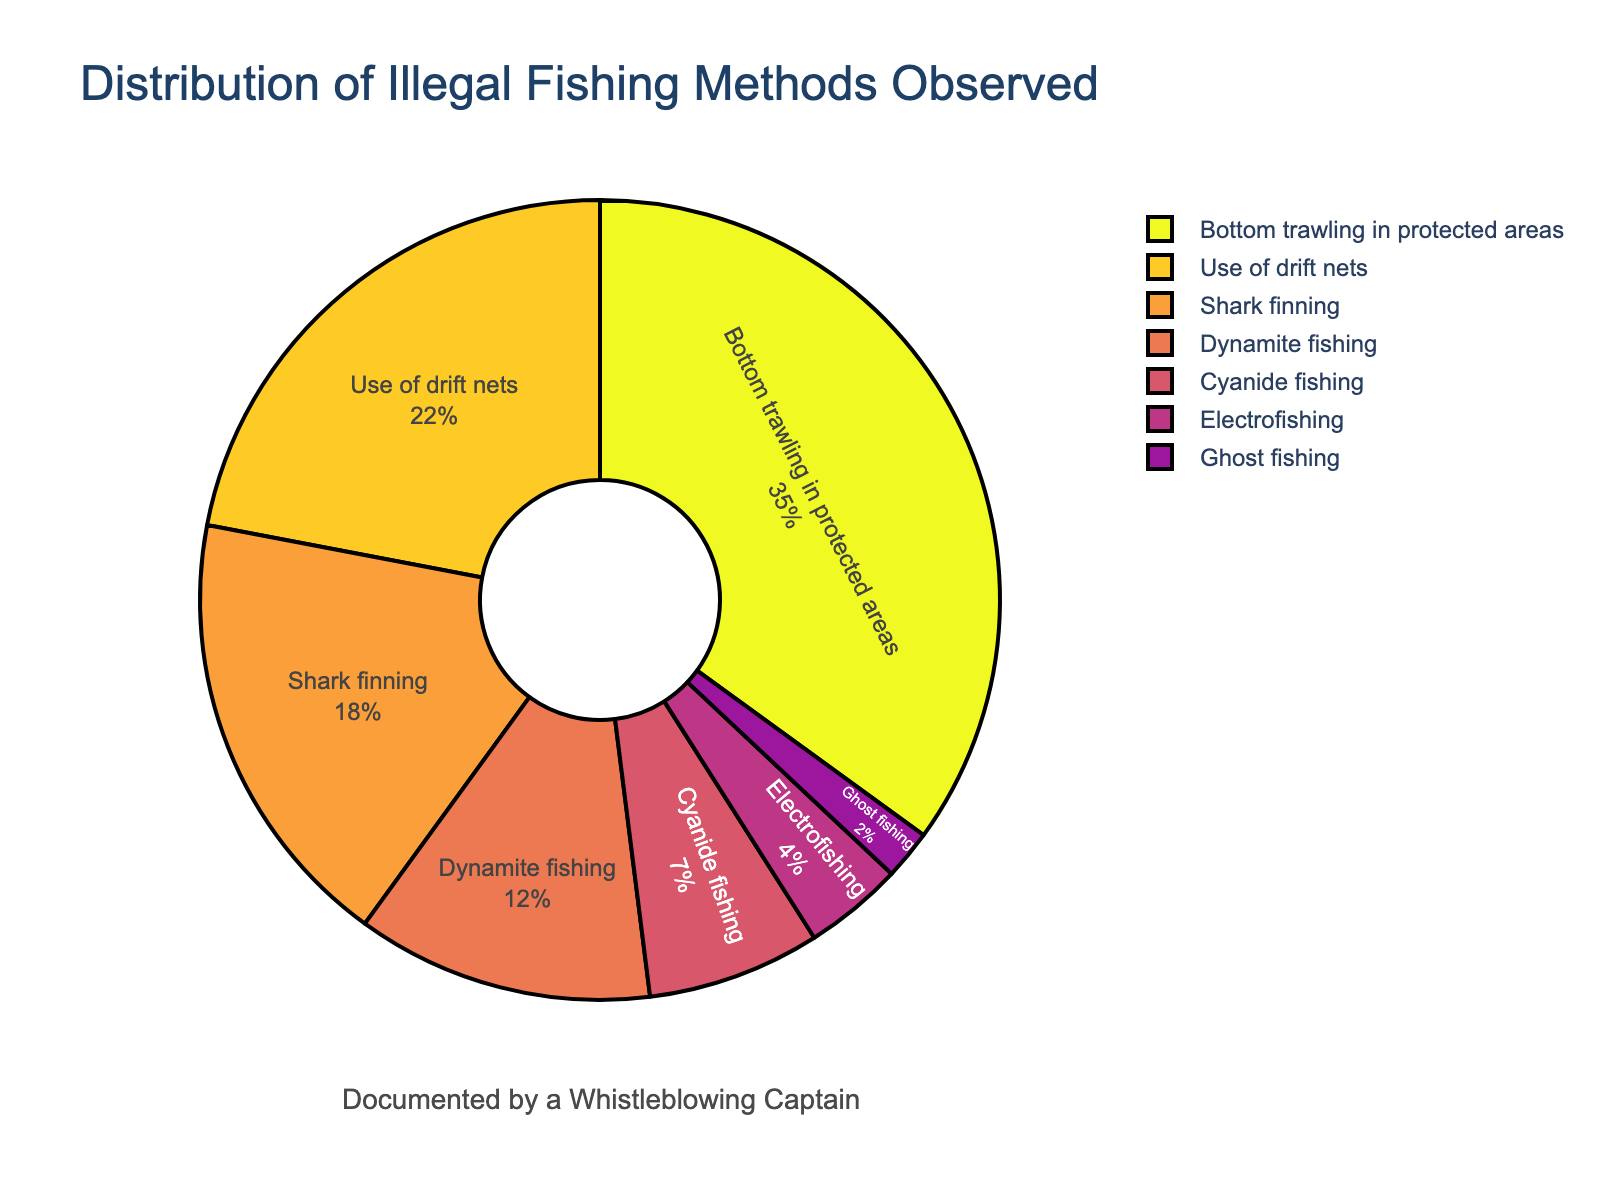Which illegal fishing method has the highest percentage? The pie chart shows different illegal fishing methods with their corresponding percentages. The highest percentage is associated with "Bottom trawling in protected areas", which has 35%.
Answer: Bottom trawling in protected areas Which illegal fishing method is observed the least? From the pie chart, the smallest segment of the circle represents "Ghost fishing", which is at 2%.
Answer: Ghost fishing How much more prevalent is bottom trawling in protected areas compared to cyanide fishing? Bottom trawling in protected areas has a 35% share, while cyanide fishing has a 7% share. The difference is 35% - 7% = 28%.
Answer: 28% What is the combined percentage of shark finning and dynamite fishing? The chart shows shark finning at 18% and dynamite fishing at 12%. The combined percentage is 18% + 12% = 30%.
Answer: 30% Which illegal fishing methods have a combined percentage of more than 50%? Adding the percentages: Bottom trawling in protected areas (35%) + Use of drift nets (22%) = 57%, which is more than 50%.
Answer: Bottom trawling in protected areas, Use of drift nets Is the use of drift nets more or less prevalent than shark finning? Use of drift nets has a 22% share, whereas shark finning has an 18% share. Since 22% > 18%, use of drift nets is more prevalent.
Answer: More Which method is represented with the smallest segment in the pie chart and what is its exact percentage? The pie chart shows the smallest segment labeled as "Ghost fishing" with a percentage of 2%.
Answer: Ghost fishing, 2% Compare the combined percentage of electrofishing and ghost fishing to the percentage of dynamite fishing. Electrofishing has 4% and ghost fishing has 2%, giving a combined total of 4% + 2% = 6%. Dynamite fishing alone is 12%, so 6% < 12%.
Answer: Less If you group dynamite fishing and cyanide fishing together, what percentage of illegal fishing methods do they make up? Dynamite fishing is 12% and cyanide fishing is 7%, so together they make up 12% + 7% = 19%.
Answer: 19% What is the percentage difference between use of drift nets and electrofishing? Use of drift nets is 22% and electrofishing is 4%. The difference is 22% - 4% = 18%.
Answer: 18% 